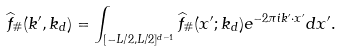Convert formula to latex. <formula><loc_0><loc_0><loc_500><loc_500>\widehat { f } _ { \# } ( k ^ { \prime } , k _ { d } ) = \int _ { [ - L / 2 , L / 2 ] ^ { d - 1 } } \widehat { f } _ { \# } ( x ^ { \prime } ; k _ { d } ) e ^ { - 2 \pi i k ^ { \prime } \cdot x ^ { \prime } } d x ^ { \prime } .</formula> 